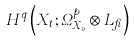Convert formula to latex. <formula><loc_0><loc_0><loc_500><loc_500>H ^ { q } \left ( X _ { t } ; \Omega _ { X _ { 0 } } ^ { p } \otimes L _ { \beta } \right )</formula> 